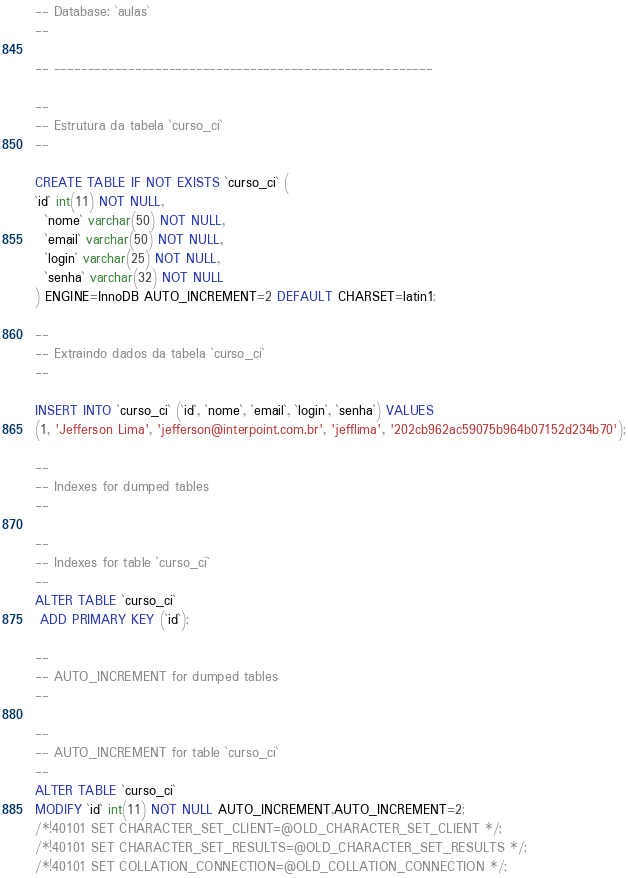Convert code to text. <code><loc_0><loc_0><loc_500><loc_500><_SQL_>-- Database: `aulas`
--

-- --------------------------------------------------------

--
-- Estrutura da tabela `curso_ci`
--

CREATE TABLE IF NOT EXISTS `curso_ci` (
`id` int(11) NOT NULL,
  `nome` varchar(50) NOT NULL,
  `email` varchar(50) NOT NULL,
  `login` varchar(25) NOT NULL,
  `senha` varchar(32) NOT NULL
) ENGINE=InnoDB AUTO_INCREMENT=2 DEFAULT CHARSET=latin1;

--
-- Extraindo dados da tabela `curso_ci`
--

INSERT INTO `curso_ci` (`id`, `nome`, `email`, `login`, `senha`) VALUES
(1, 'Jefferson Lima', 'jefferson@interpoint.com.br', 'jefflima', '202cb962ac59075b964b07152d234b70');

--
-- Indexes for dumped tables
--

--
-- Indexes for table `curso_ci`
--
ALTER TABLE `curso_ci`
 ADD PRIMARY KEY (`id`);

--
-- AUTO_INCREMENT for dumped tables
--

--
-- AUTO_INCREMENT for table `curso_ci`
--
ALTER TABLE `curso_ci`
MODIFY `id` int(11) NOT NULL AUTO_INCREMENT,AUTO_INCREMENT=2;
/*!40101 SET CHARACTER_SET_CLIENT=@OLD_CHARACTER_SET_CLIENT */;
/*!40101 SET CHARACTER_SET_RESULTS=@OLD_CHARACTER_SET_RESULTS */;
/*!40101 SET COLLATION_CONNECTION=@OLD_COLLATION_CONNECTION */;
</code> 